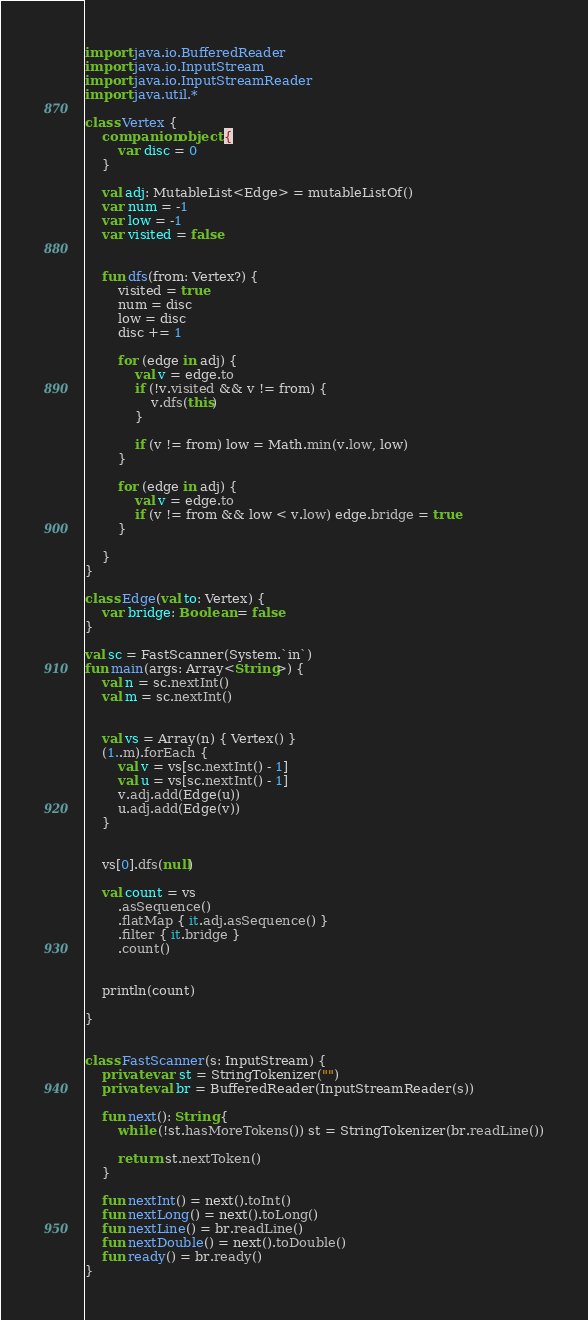<code> <loc_0><loc_0><loc_500><loc_500><_Kotlin_>import java.io.BufferedReader
import java.io.InputStream
import java.io.InputStreamReader
import java.util.*

class Vertex {
    companion object {
        var disc = 0
    }

    val adj: MutableList<Edge> = mutableListOf()
    var num = -1
    var low = -1
    var visited = false


    fun dfs(from: Vertex?) {
        visited = true
        num = disc
        low = disc
        disc += 1

        for (edge in adj) {
            val v = edge.to
            if (!v.visited && v != from) {
                v.dfs(this)
            }

            if (v != from) low = Math.min(v.low, low)
        }

        for (edge in adj) {
            val v = edge.to
            if (v != from && low < v.low) edge.bridge = true
        }

    }
}

class Edge(val to: Vertex) {
    var bridge: Boolean = false
}

val sc = FastScanner(System.`in`)
fun main(args: Array<String>) {
    val n = sc.nextInt()
    val m = sc.nextInt()


    val vs = Array(n) { Vertex() }
    (1..m).forEach {
        val v = vs[sc.nextInt() - 1]
        val u = vs[sc.nextInt() - 1]
        v.adj.add(Edge(u))
        u.adj.add(Edge(v))
    }


    vs[0].dfs(null)

    val count = vs
        .asSequence()
        .flatMap { it.adj.asSequence() }
        .filter { it.bridge }
        .count()


    println(count)

}


class FastScanner(s: InputStream) {
    private var st = StringTokenizer("")
    private val br = BufferedReader(InputStreamReader(s))

    fun next(): String {
        while (!st.hasMoreTokens()) st = StringTokenizer(br.readLine())

        return st.nextToken()
    }

    fun nextInt() = next().toInt()
    fun nextLong() = next().toLong()
    fun nextLine() = br.readLine()
    fun nextDouble() = next().toDouble()
    fun ready() = br.ready()
}


</code> 